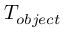Convert formula to latex. <formula><loc_0><loc_0><loc_500><loc_500>T _ { o b j e c t }</formula> 